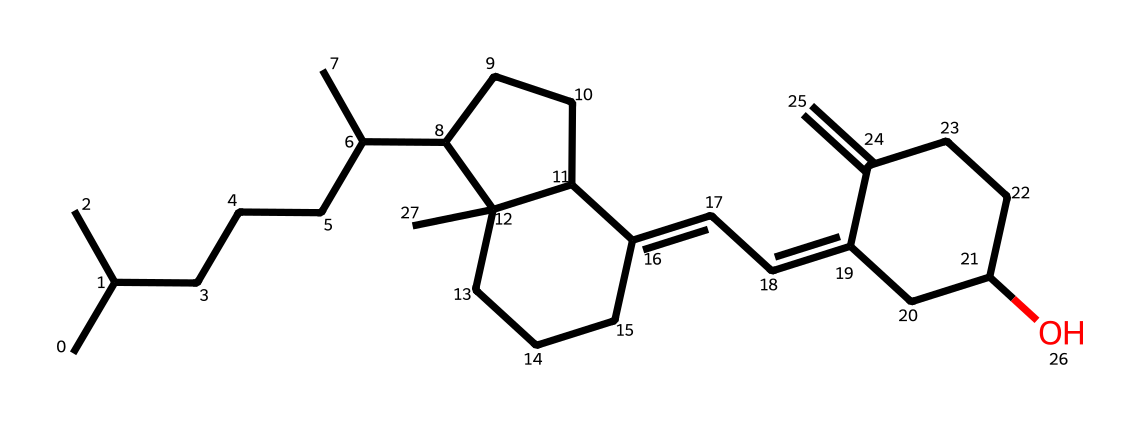how many carbon atoms are in this structure? To determine the number of carbon atoms, I will count all the 'C' symbols in the SMILES representation. Each 'C' corresponds to a carbon atom, and I will also consider the branching as indicated by parentheses. After counting, there are 27 carbon atoms in the structure.
Answer: 27 how many rings are present in this chemical structure? A ring in a chemical structure can be identified by the numbers in the SMILES representation that indicate the starting and ending atoms of a cycle. There are two instances of numbers: '1' and '2', which indicate two distinct ring closures. Thus, there are two rings present in the structure.
Answer: 2 what type of vitamin is represented by this molecule? Vitamin D is characterized by the presence of specific sterol structures and its role in calcium metabolism. The provided SMILES represents a vitamin that closely resembles vitamin D based on molecular structure and biological roles.
Answer: vitamin D does this molecule contain hydroxyl (–OH) groups? To check for the presence of hydroxyl groups, I will look for the letter 'O' in the SMILES, as it often indicates an oxygen that can connect to a hydrogen atom, forming –OH groups. In the SMILES, there is a single 'O' appearing in the structure, confirming the presence of one hydroxyl group.
Answer: yes is this molecule hydrophilic or hydrophobic? The hydrophilicity or hydrophobicity can be inferred from the presence of polar functional groups versus long carbon chains. Since this molecule has a long carbon chain with a hydroxyl group (which is polar but minor compared to the overall structure), it is primarily hydrophobic despite the hydroxyl group.
Answer: hydrophobic how many double bonds does this molecule have? Double bonds in SMILES can typically be indicated by the presence of '=' symbols. By scanning through the structure, I can count three instances of '=' in the SMILES representation, showing that there are three double bonds present.
Answer: 3 